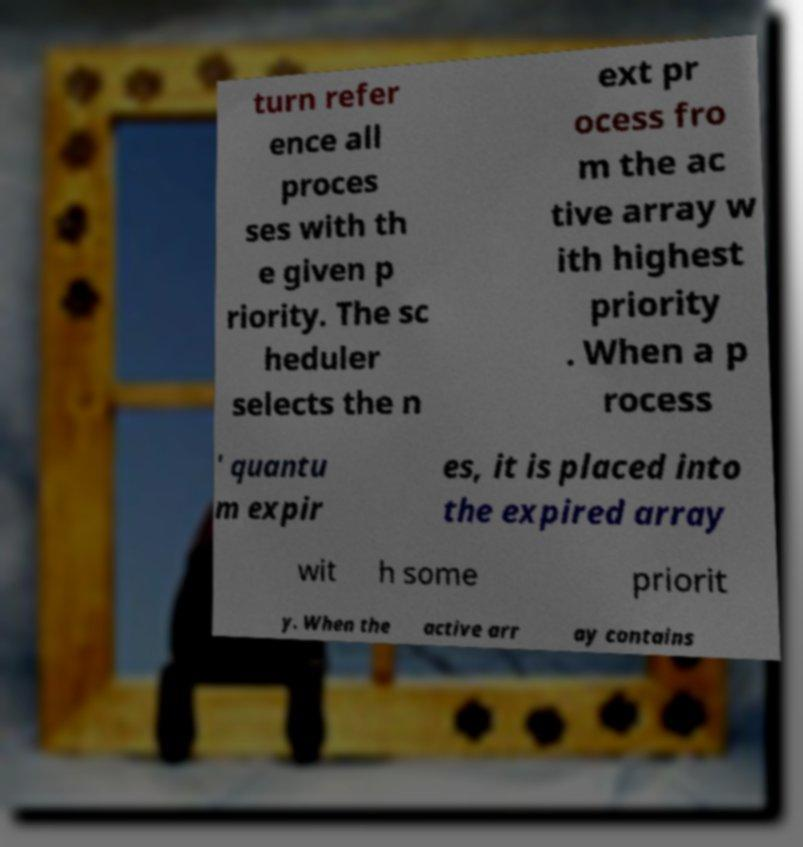I need the written content from this picture converted into text. Can you do that? turn refer ence all proces ses with th e given p riority. The sc heduler selects the n ext pr ocess fro m the ac tive array w ith highest priority . When a p rocess ' quantu m expir es, it is placed into the expired array wit h some priorit y. When the active arr ay contains 